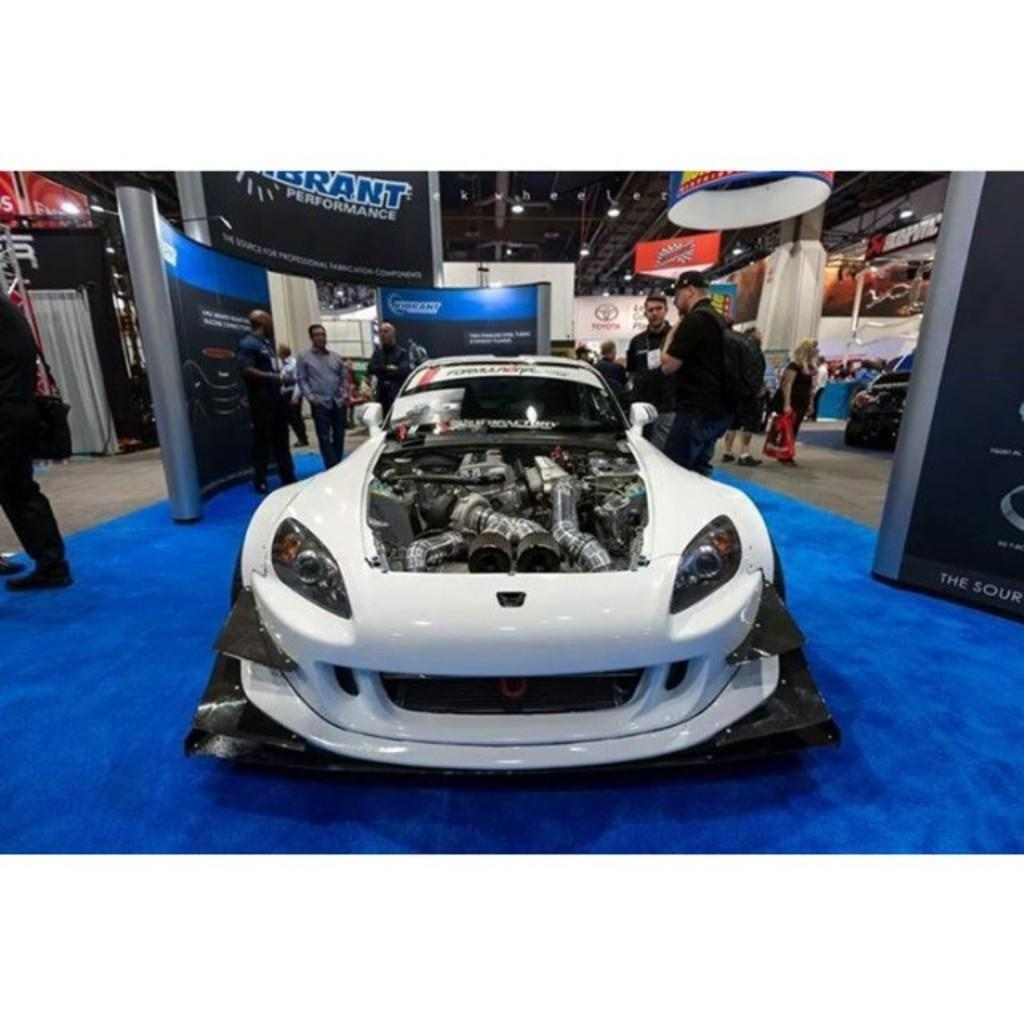What is the main subject of the image? There is a vehicle in the image. Can you describe the people in the image? There are people in the image. What is the surface on which the vehicle and people are situated? There is a floor in the image. What is present in the background of the image? There are hoardings and lights in the image. What type of covering is present in the image? There is a curtain in the image. What other objects can be seen in the image? There are boards and other objects in the image. What type of calculator can be seen on the edge of the vehicle in the image? There is no calculator present on the edge of the vehicle in the image. 